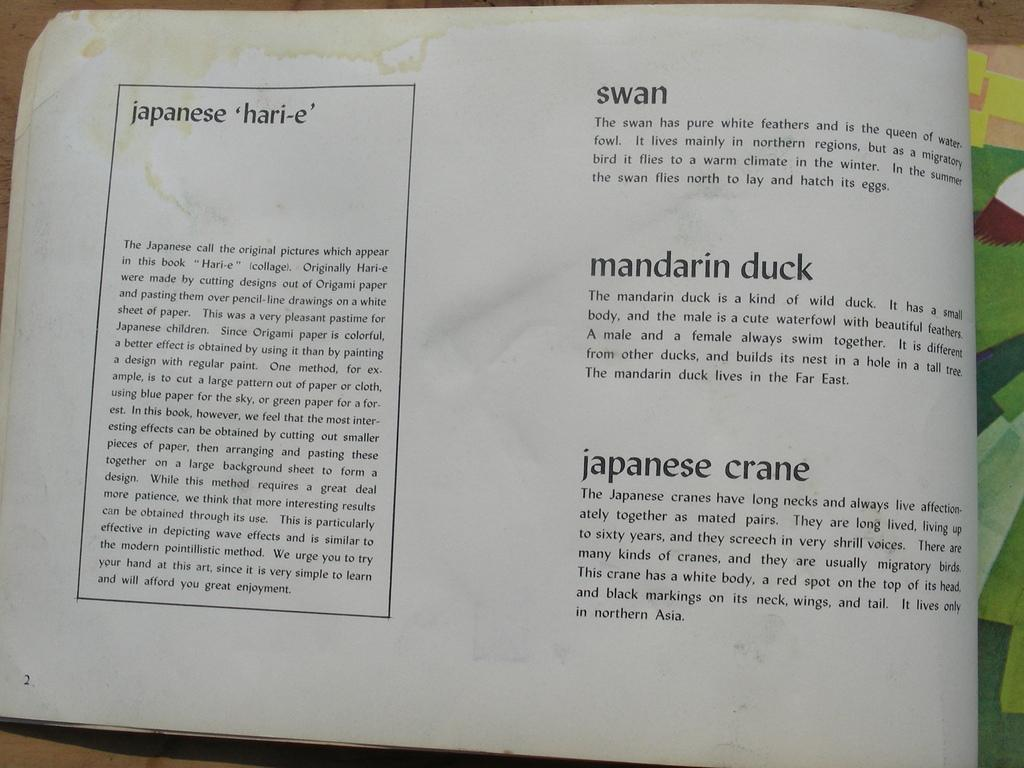<image>
Render a clear and concise summary of the photo. open book that is stained at top, has paragraphs for swan, mandarin duck, and japanese crane 